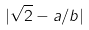<formula> <loc_0><loc_0><loc_500><loc_500>| \sqrt { 2 } - a / b |</formula> 